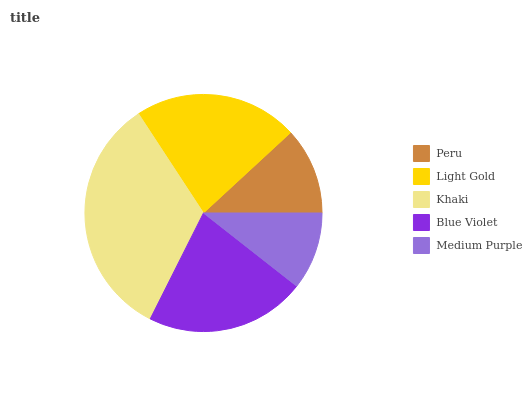Is Medium Purple the minimum?
Answer yes or no. Yes. Is Khaki the maximum?
Answer yes or no. Yes. Is Light Gold the minimum?
Answer yes or no. No. Is Light Gold the maximum?
Answer yes or no. No. Is Light Gold greater than Peru?
Answer yes or no. Yes. Is Peru less than Light Gold?
Answer yes or no. Yes. Is Peru greater than Light Gold?
Answer yes or no. No. Is Light Gold less than Peru?
Answer yes or no. No. Is Blue Violet the high median?
Answer yes or no. Yes. Is Blue Violet the low median?
Answer yes or no. Yes. Is Light Gold the high median?
Answer yes or no. No. Is Khaki the low median?
Answer yes or no. No. 